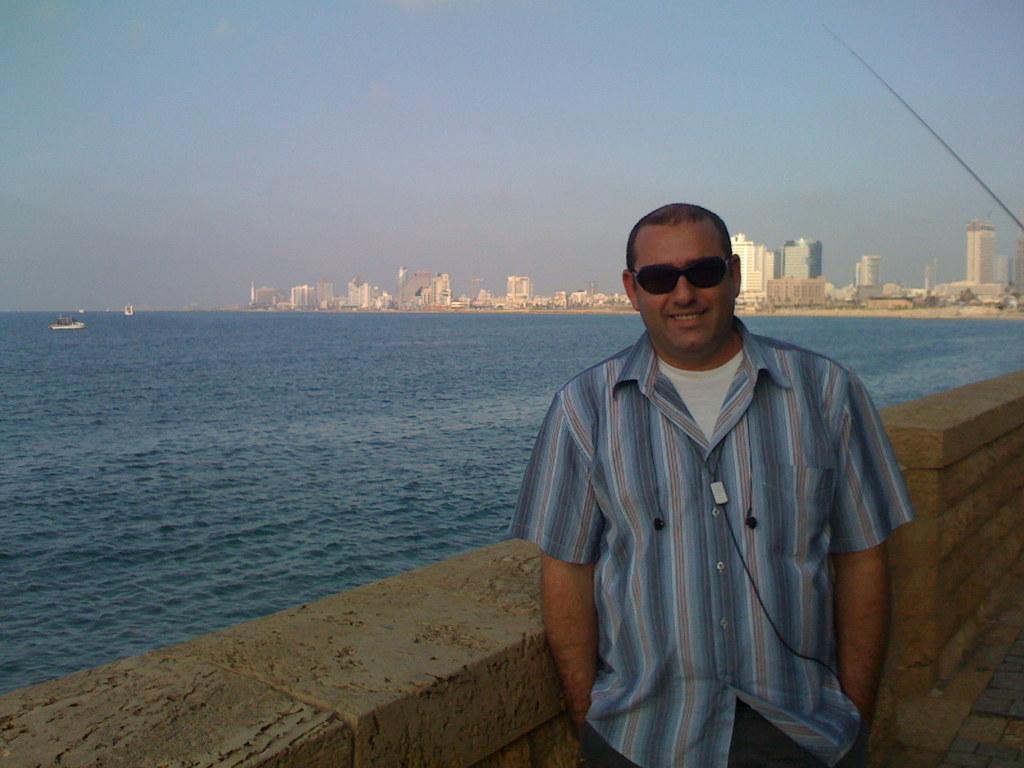In one or two sentences, can you explain what this image depicts? On the right side of the image we can see a man standing and smiling. There is a wall. In the background we can see a sea and there are boats. There are buildings. At the top there is sky. 